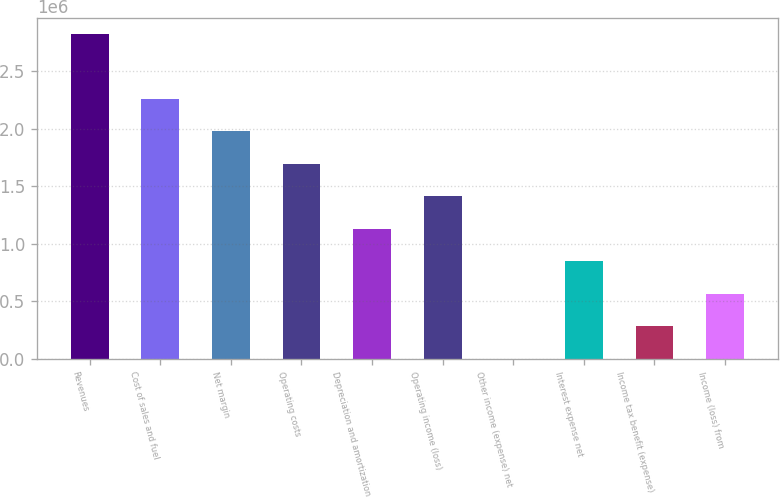Convert chart. <chart><loc_0><loc_0><loc_500><loc_500><bar_chart><fcel>Revenues<fcel>Cost of sales and fuel<fcel>Net margin<fcel>Operating costs<fcel>Depreciation and amortization<fcel>Operating income (loss)<fcel>Other income (expense) net<fcel>Interest expense net<fcel>Income tax benefit (expense)<fcel>Income (loss) from<nl><fcel>2.82542e+06<fcel>2.26065e+06<fcel>1.97827e+06<fcel>1.69589e+06<fcel>1.13112e+06<fcel>1.4135e+06<fcel>1586<fcel>848736<fcel>283969<fcel>566353<nl></chart> 